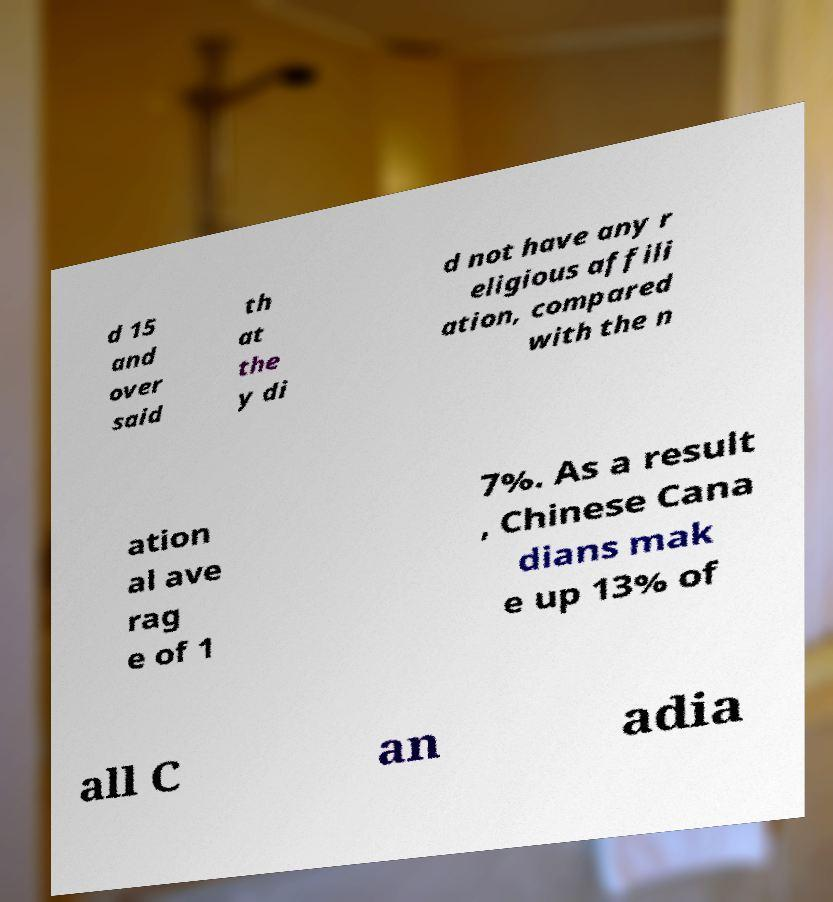Can you read and provide the text displayed in the image?This photo seems to have some interesting text. Can you extract and type it out for me? d 15 and over said th at the y di d not have any r eligious affili ation, compared with the n ation al ave rag e of 1 7%. As a result , Chinese Cana dians mak e up 13% of all C an adia 